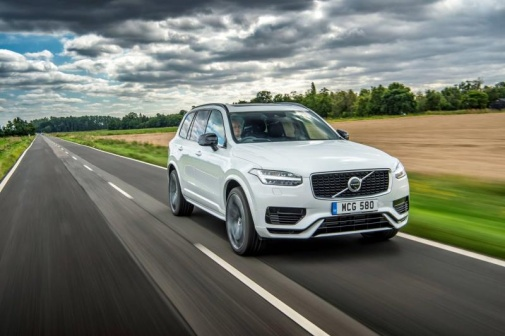If you could rename the SUV based on this scene, what would you call it? I would rename the SUV 'Voyager Tranquility' to capture the essence of the peaceful journey it is on, navigating through the serene countryside setting. 